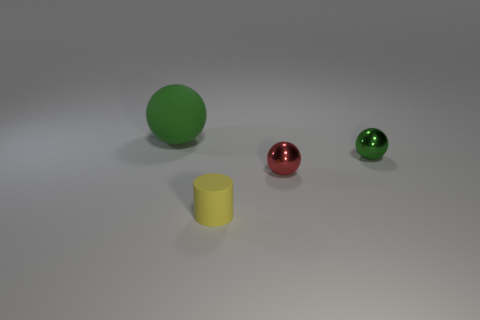Subtract all tiny shiny balls. How many balls are left? 1 Subtract all yellow cylinders. How many green spheres are left? 2 Subtract all spheres. How many objects are left? 1 Subtract 1 balls. How many balls are left? 2 Add 1 green matte things. How many objects exist? 5 Subtract 0 yellow cubes. How many objects are left? 4 Subtract all brown cylinders. Subtract all purple spheres. How many cylinders are left? 1 Subtract all green matte spheres. Subtract all big green objects. How many objects are left? 2 Add 1 spheres. How many spheres are left? 4 Add 1 tiny blue rubber cylinders. How many tiny blue rubber cylinders exist? 1 